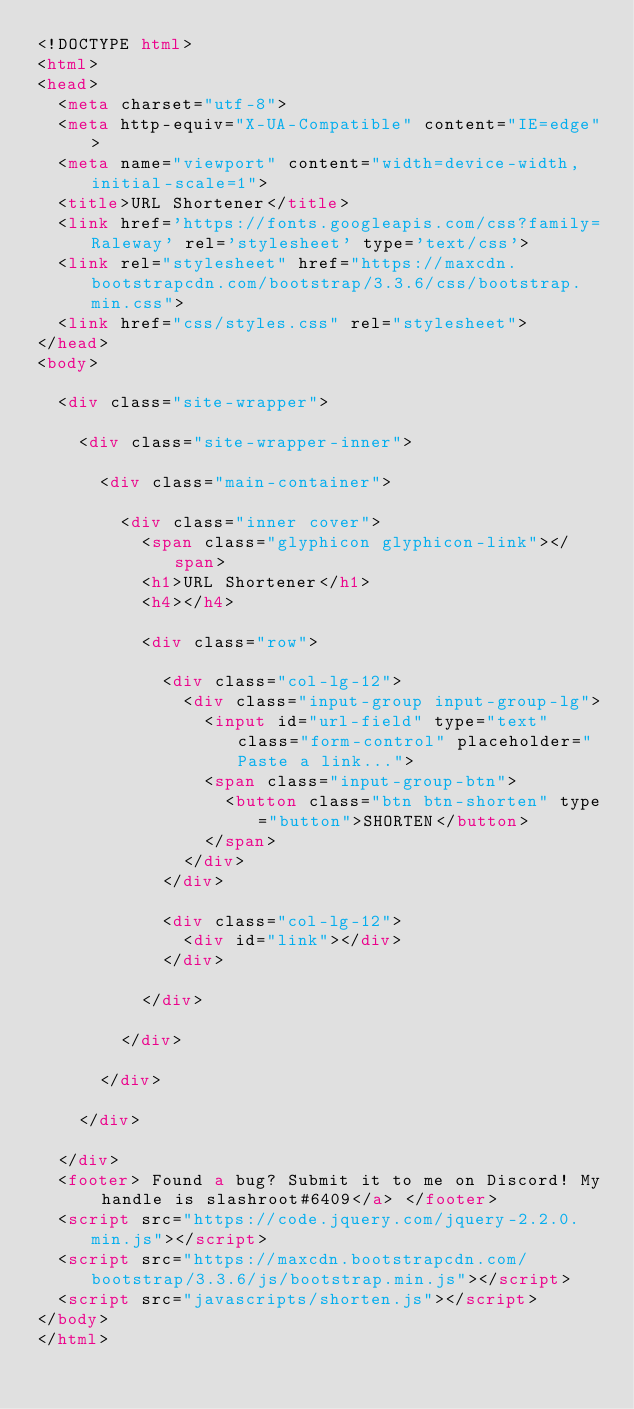<code> <loc_0><loc_0><loc_500><loc_500><_HTML_><!DOCTYPE html>
<html>
<head>
  <meta charset="utf-8">
  <meta http-equiv="X-UA-Compatible" content="IE=edge">
  <meta name="viewport" content="width=device-width, initial-scale=1">
  <title>URL Shortener</title>
  <link href='https://fonts.googleapis.com/css?family=Raleway' rel='stylesheet' type='text/css'>
  <link rel="stylesheet" href="https://maxcdn.bootstrapcdn.com/bootstrap/3.3.6/css/bootstrap.min.css">
  <link href="css/styles.css" rel="stylesheet">
</head>
<body>

  <div class="site-wrapper">

    <div class="site-wrapper-inner">

      <div class="main-container">

        <div class="inner cover">
          <span class="glyphicon glyphicon-link"></span>
          <h1>URL Shortener</h1>
          <h4></h4>

          <div class="row">

            <div class="col-lg-12">
              <div class="input-group input-group-lg">
                <input id="url-field" type="text" class="form-control" placeholder="Paste a link...">
                <span class="input-group-btn">
                  <button class="btn btn-shorten" type="button">SHORTEN</button>
                </span>
              </div>
            </div>

            <div class="col-lg-12">
              <div id="link"></div>
            </div>

          </div>

        </div>

      </div>

    </div>

  </div>
  <footer> Found a bug? Submit it to me on Discord! My handle is slashroot#6409</a> </footer>
  <script src="https://code.jquery.com/jquery-2.2.0.min.js"></script>
  <script src="https://maxcdn.bootstrapcdn.com/bootstrap/3.3.6/js/bootstrap.min.js"></script>
  <script src="javascripts/shorten.js"></script>
</body>
</html>
</code> 